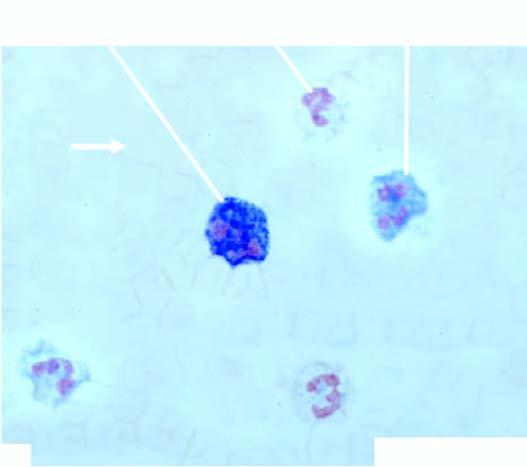what is accompanied with late precursors of myeloid series?
Answer the question using a single word or phrase. Peripheral blood film showing marked neutrophilic leucocytosis 